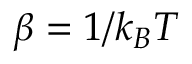Convert formula to latex. <formula><loc_0><loc_0><loc_500><loc_500>\beta = 1 / k _ { B } T</formula> 